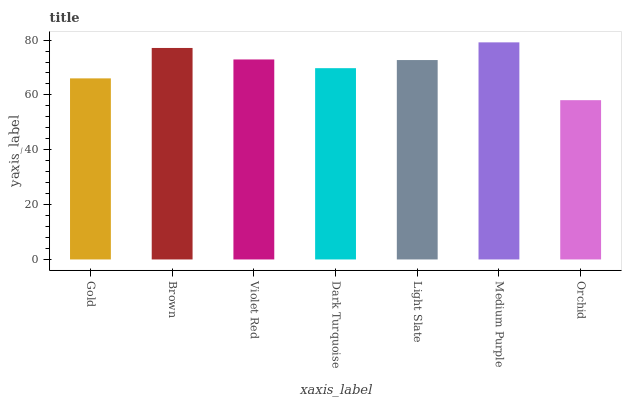Is Brown the minimum?
Answer yes or no. No. Is Brown the maximum?
Answer yes or no. No. Is Brown greater than Gold?
Answer yes or no. Yes. Is Gold less than Brown?
Answer yes or no. Yes. Is Gold greater than Brown?
Answer yes or no. No. Is Brown less than Gold?
Answer yes or no. No. Is Light Slate the high median?
Answer yes or no. Yes. Is Light Slate the low median?
Answer yes or no. Yes. Is Dark Turquoise the high median?
Answer yes or no. No. Is Violet Red the low median?
Answer yes or no. No. 